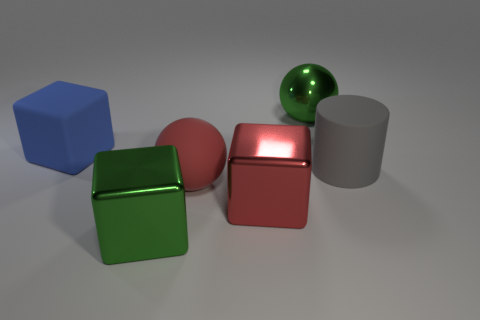Subtract all big red shiny cubes. How many cubes are left? 2 Subtract 1 blocks. How many blocks are left? 2 Add 1 large rubber objects. How many objects exist? 7 Subtract all cylinders. How many objects are left? 5 Add 1 green metal cubes. How many green metal cubes are left? 2 Add 5 tiny cyan matte things. How many tiny cyan matte things exist? 5 Subtract 1 blue blocks. How many objects are left? 5 Subtract all metallic things. Subtract all gray things. How many objects are left? 2 